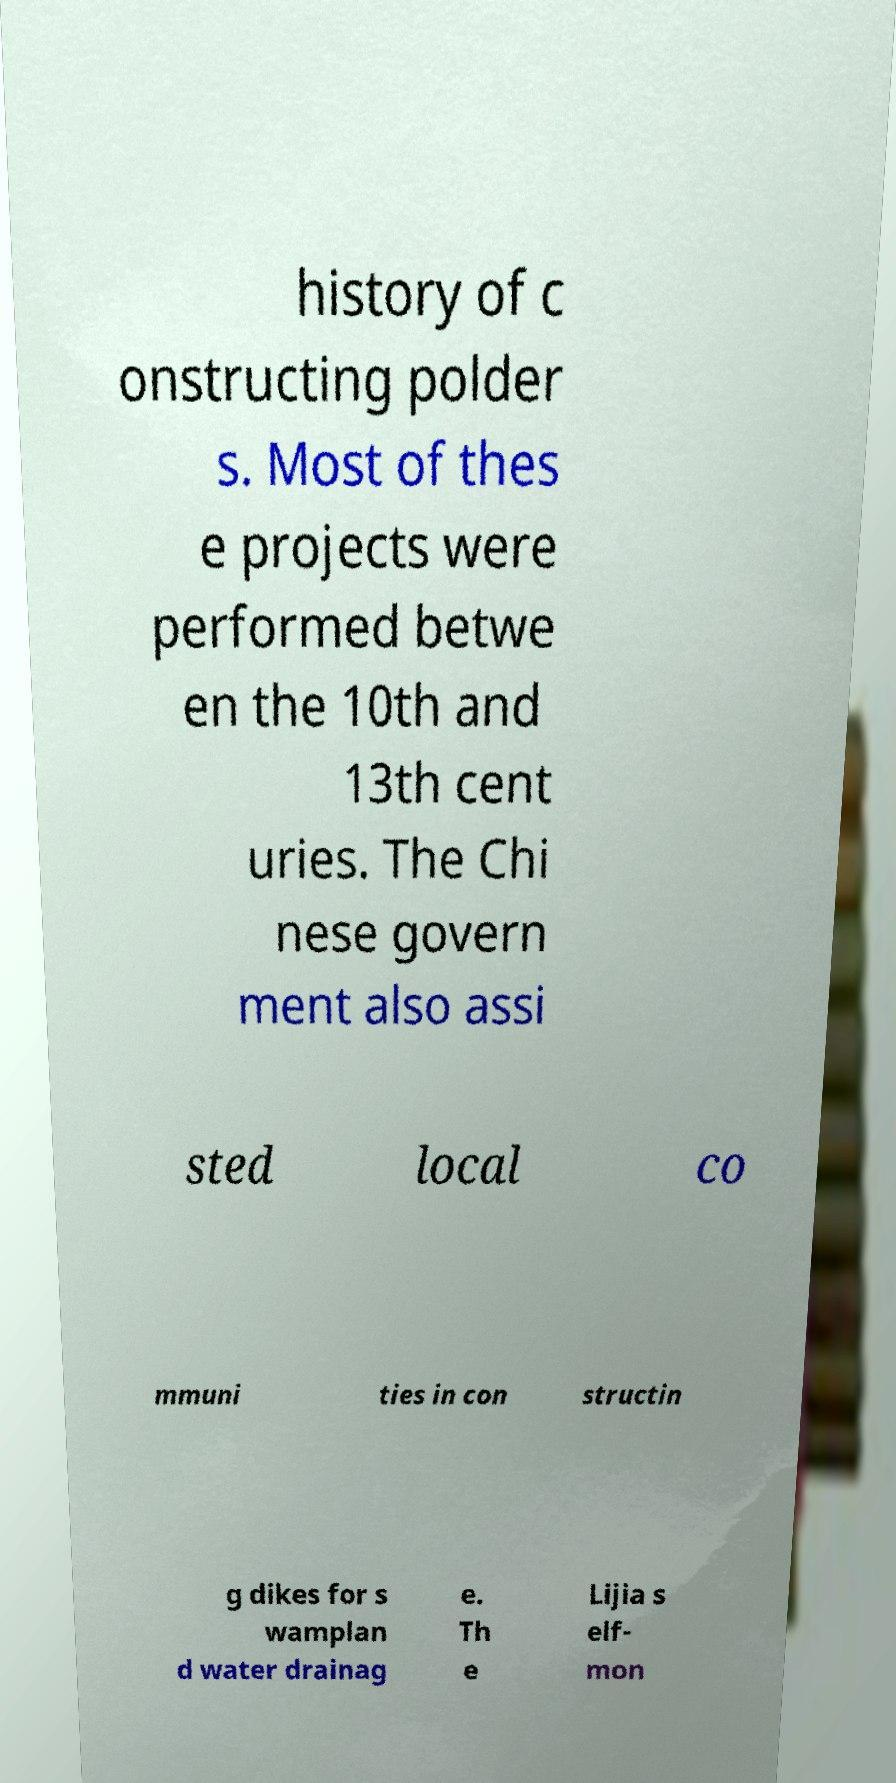What messages or text are displayed in this image? I need them in a readable, typed format. history of c onstructing polder s. Most of thes e projects were performed betwe en the 10th and 13th cent uries. The Chi nese govern ment also assi sted local co mmuni ties in con structin g dikes for s wamplan d water drainag e. Th e Lijia s elf- mon 